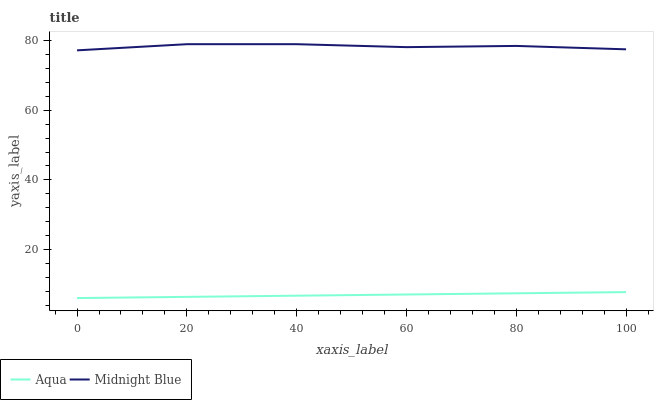Does Aqua have the minimum area under the curve?
Answer yes or no. Yes. Does Midnight Blue have the maximum area under the curve?
Answer yes or no. Yes. Does Midnight Blue have the minimum area under the curve?
Answer yes or no. No. Is Aqua the smoothest?
Answer yes or no. Yes. Is Midnight Blue the roughest?
Answer yes or no. Yes. Is Midnight Blue the smoothest?
Answer yes or no. No. Does Aqua have the lowest value?
Answer yes or no. Yes. Does Midnight Blue have the lowest value?
Answer yes or no. No. Does Midnight Blue have the highest value?
Answer yes or no. Yes. Is Aqua less than Midnight Blue?
Answer yes or no. Yes. Is Midnight Blue greater than Aqua?
Answer yes or no. Yes. Does Aqua intersect Midnight Blue?
Answer yes or no. No. 